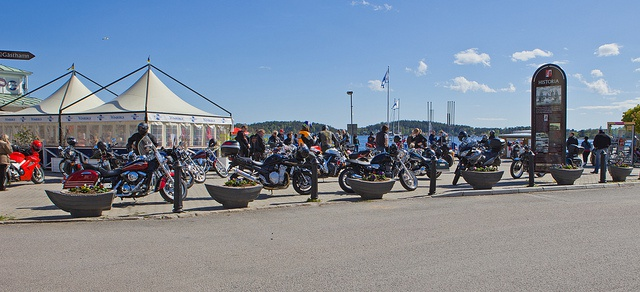Describe the objects in this image and their specific colors. I can see motorcycle in gray, black, maroon, and navy tones, motorcycle in gray, black, and navy tones, people in gray, black, blue, and navy tones, potted plant in gray, black, olive, and darkgray tones, and motorcycle in gray, black, darkgray, and navy tones in this image. 